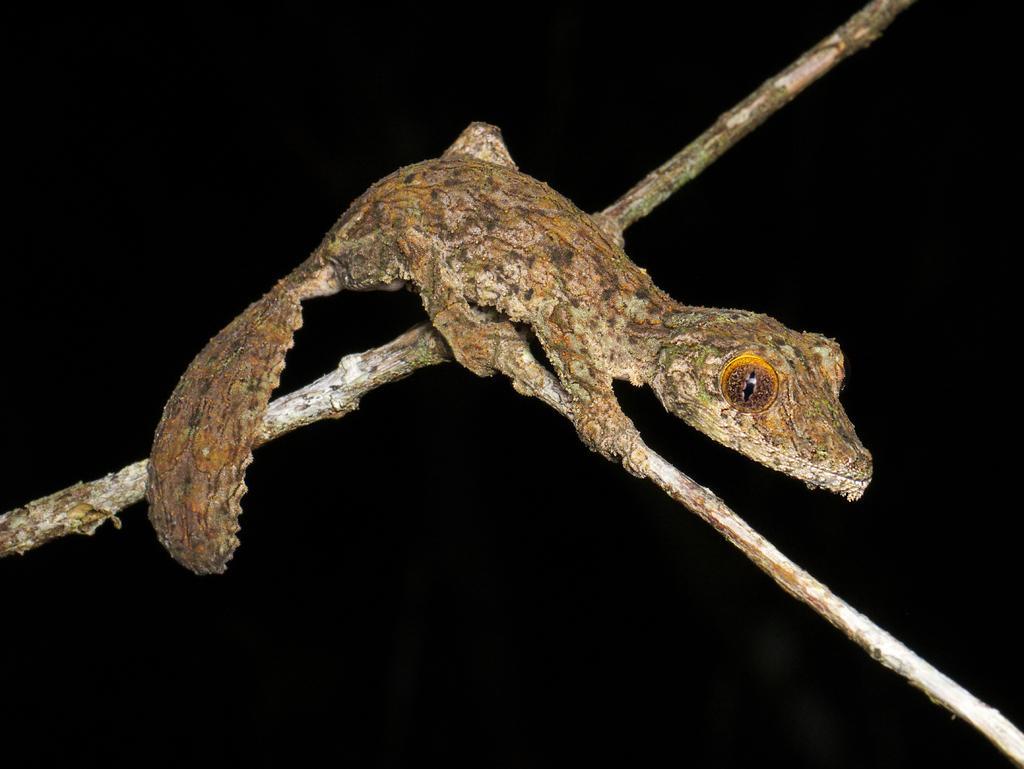How would you summarize this image in a sentence or two? In this picture I can see there is a lizard and it is having eyes, body and a tail. It is sitting on the stem and the backdrop is dark. 